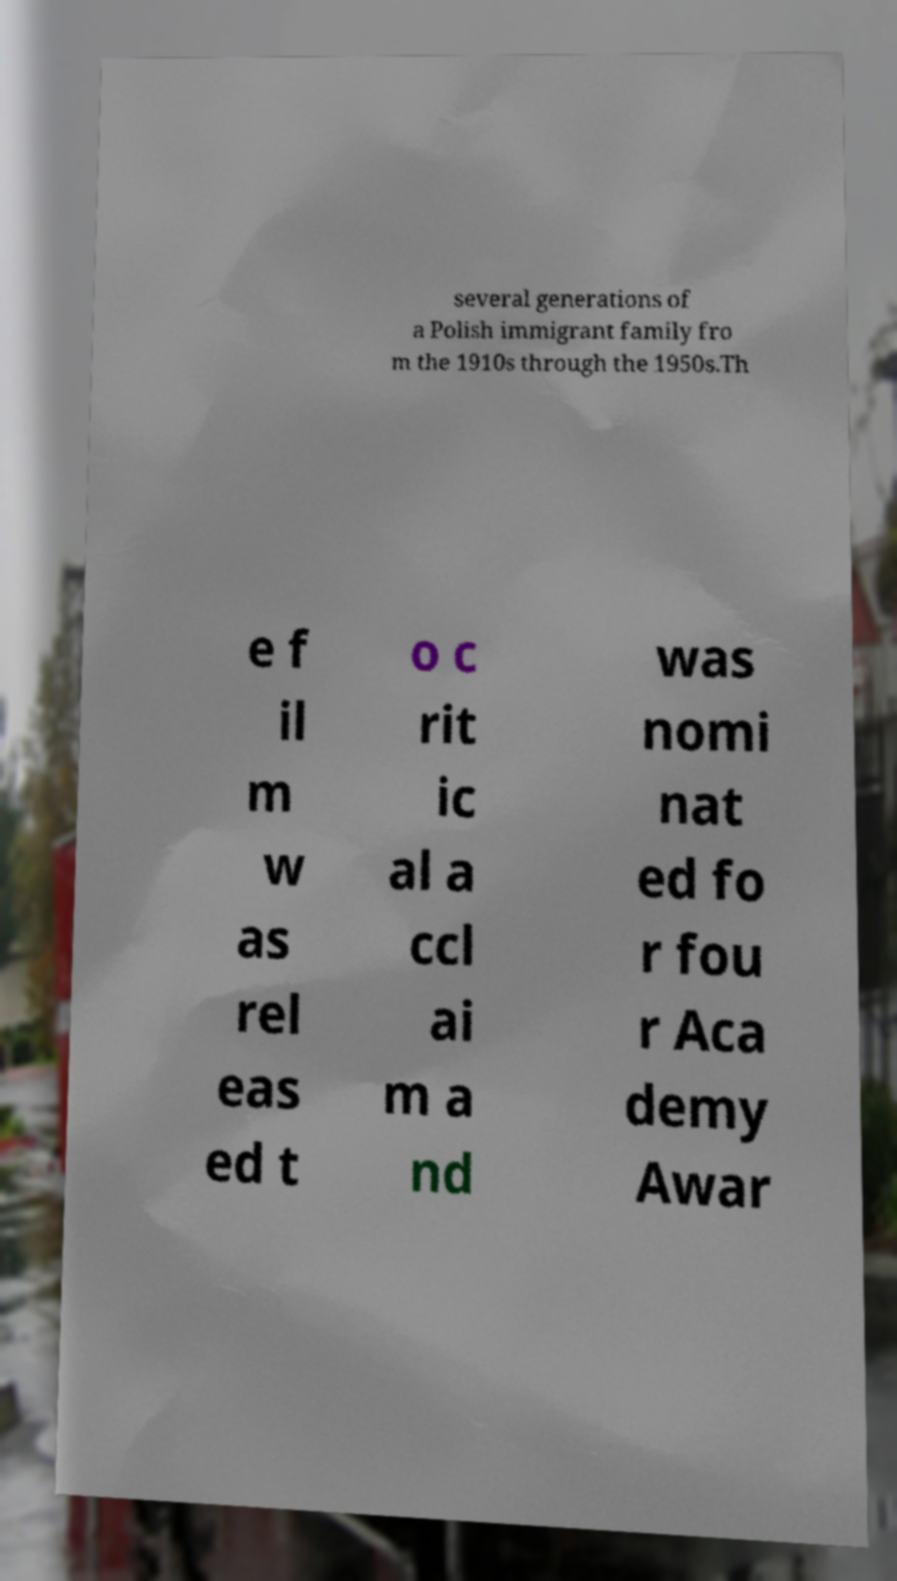I need the written content from this picture converted into text. Can you do that? several generations of a Polish immigrant family fro m the 1910s through the 1950s.Th e f il m w as rel eas ed t o c rit ic al a ccl ai m a nd was nomi nat ed fo r fou r Aca demy Awar 